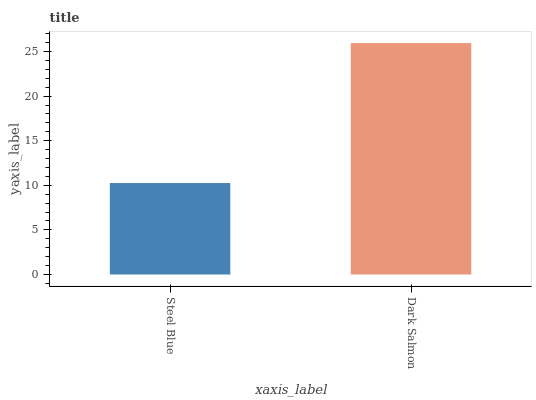Is Steel Blue the minimum?
Answer yes or no. Yes. Is Dark Salmon the maximum?
Answer yes or no. Yes. Is Dark Salmon the minimum?
Answer yes or no. No. Is Dark Salmon greater than Steel Blue?
Answer yes or no. Yes. Is Steel Blue less than Dark Salmon?
Answer yes or no. Yes. Is Steel Blue greater than Dark Salmon?
Answer yes or no. No. Is Dark Salmon less than Steel Blue?
Answer yes or no. No. Is Dark Salmon the high median?
Answer yes or no. Yes. Is Steel Blue the low median?
Answer yes or no. Yes. Is Steel Blue the high median?
Answer yes or no. No. Is Dark Salmon the low median?
Answer yes or no. No. 